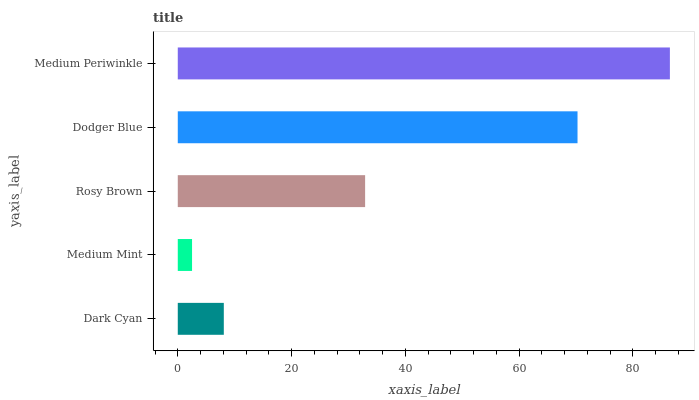Is Medium Mint the minimum?
Answer yes or no. Yes. Is Medium Periwinkle the maximum?
Answer yes or no. Yes. Is Rosy Brown the minimum?
Answer yes or no. No. Is Rosy Brown the maximum?
Answer yes or no. No. Is Rosy Brown greater than Medium Mint?
Answer yes or no. Yes. Is Medium Mint less than Rosy Brown?
Answer yes or no. Yes. Is Medium Mint greater than Rosy Brown?
Answer yes or no. No. Is Rosy Brown less than Medium Mint?
Answer yes or no. No. Is Rosy Brown the high median?
Answer yes or no. Yes. Is Rosy Brown the low median?
Answer yes or no. Yes. Is Dark Cyan the high median?
Answer yes or no. No. Is Dark Cyan the low median?
Answer yes or no. No. 